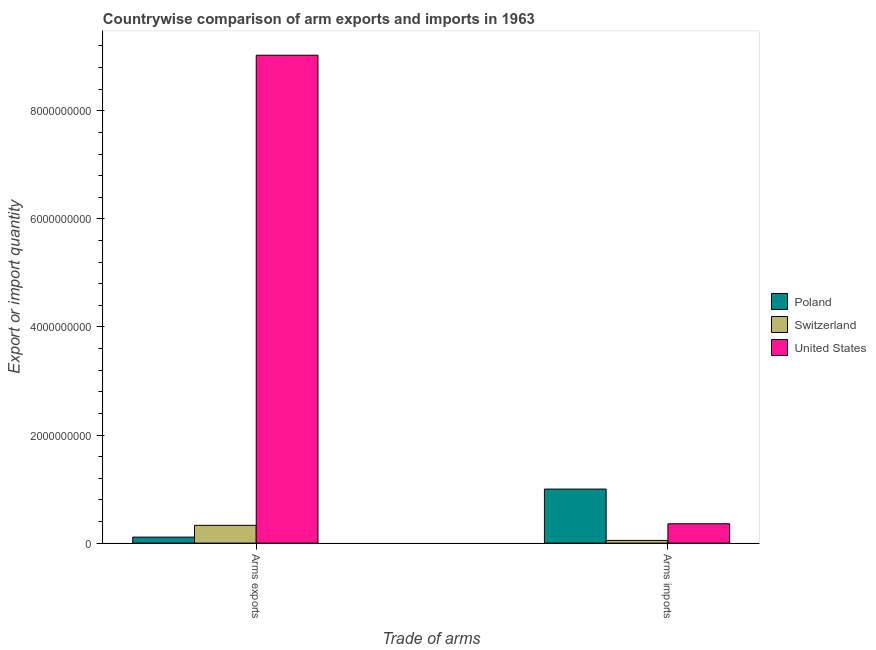How many different coloured bars are there?
Make the answer very short. 3. How many bars are there on the 2nd tick from the left?
Ensure brevity in your answer.  3. What is the label of the 2nd group of bars from the left?
Give a very brief answer. Arms imports. What is the arms imports in Switzerland?
Give a very brief answer. 5.00e+07. Across all countries, what is the maximum arms exports?
Provide a succinct answer. 9.03e+09. Across all countries, what is the minimum arms exports?
Offer a very short reply. 1.11e+08. What is the total arms imports in the graph?
Provide a short and direct response. 1.41e+09. What is the difference between the arms exports in United States and that in Switzerland?
Offer a very short reply. 8.70e+09. What is the difference between the arms exports in Poland and the arms imports in United States?
Ensure brevity in your answer.  -2.47e+08. What is the average arms imports per country?
Your answer should be compact. 4.69e+08. What is the difference between the arms imports and arms exports in Poland?
Your answer should be compact. 8.89e+08. In how many countries, is the arms imports greater than 7200000000 ?
Keep it short and to the point. 0. What is the ratio of the arms exports in United States to that in Switzerland?
Keep it short and to the point. 27.44. What does the 3rd bar from the left in Arms exports represents?
Your response must be concise. United States. What does the 1st bar from the right in Arms exports represents?
Your answer should be very brief. United States. What is the difference between two consecutive major ticks on the Y-axis?
Offer a terse response. 2.00e+09. Does the graph contain any zero values?
Your response must be concise. No. Does the graph contain grids?
Give a very brief answer. No. Where does the legend appear in the graph?
Make the answer very short. Center right. How many legend labels are there?
Offer a terse response. 3. How are the legend labels stacked?
Keep it short and to the point. Vertical. What is the title of the graph?
Your answer should be very brief. Countrywise comparison of arm exports and imports in 1963. What is the label or title of the X-axis?
Make the answer very short. Trade of arms. What is the label or title of the Y-axis?
Offer a very short reply. Export or import quantity. What is the Export or import quantity of Poland in Arms exports?
Ensure brevity in your answer.  1.11e+08. What is the Export or import quantity in Switzerland in Arms exports?
Ensure brevity in your answer.  3.29e+08. What is the Export or import quantity in United States in Arms exports?
Provide a succinct answer. 9.03e+09. What is the Export or import quantity of Poland in Arms imports?
Keep it short and to the point. 1.00e+09. What is the Export or import quantity in Switzerland in Arms imports?
Ensure brevity in your answer.  5.00e+07. What is the Export or import quantity in United States in Arms imports?
Your response must be concise. 3.58e+08. Across all Trade of arms, what is the maximum Export or import quantity of Switzerland?
Your answer should be very brief. 3.29e+08. Across all Trade of arms, what is the maximum Export or import quantity in United States?
Provide a succinct answer. 9.03e+09. Across all Trade of arms, what is the minimum Export or import quantity in Poland?
Make the answer very short. 1.11e+08. Across all Trade of arms, what is the minimum Export or import quantity in United States?
Ensure brevity in your answer.  3.58e+08. What is the total Export or import quantity of Poland in the graph?
Offer a terse response. 1.11e+09. What is the total Export or import quantity of Switzerland in the graph?
Offer a very short reply. 3.79e+08. What is the total Export or import quantity in United States in the graph?
Give a very brief answer. 9.39e+09. What is the difference between the Export or import quantity in Poland in Arms exports and that in Arms imports?
Offer a very short reply. -8.89e+08. What is the difference between the Export or import quantity of Switzerland in Arms exports and that in Arms imports?
Ensure brevity in your answer.  2.79e+08. What is the difference between the Export or import quantity of United States in Arms exports and that in Arms imports?
Provide a short and direct response. 8.67e+09. What is the difference between the Export or import quantity of Poland in Arms exports and the Export or import quantity of Switzerland in Arms imports?
Ensure brevity in your answer.  6.10e+07. What is the difference between the Export or import quantity in Poland in Arms exports and the Export or import quantity in United States in Arms imports?
Offer a terse response. -2.47e+08. What is the difference between the Export or import quantity in Switzerland in Arms exports and the Export or import quantity in United States in Arms imports?
Give a very brief answer. -2.90e+07. What is the average Export or import quantity of Poland per Trade of arms?
Provide a succinct answer. 5.56e+08. What is the average Export or import quantity in Switzerland per Trade of arms?
Offer a very short reply. 1.90e+08. What is the average Export or import quantity of United States per Trade of arms?
Offer a terse response. 4.69e+09. What is the difference between the Export or import quantity of Poland and Export or import quantity of Switzerland in Arms exports?
Offer a terse response. -2.18e+08. What is the difference between the Export or import quantity in Poland and Export or import quantity in United States in Arms exports?
Provide a short and direct response. -8.92e+09. What is the difference between the Export or import quantity in Switzerland and Export or import quantity in United States in Arms exports?
Offer a very short reply. -8.70e+09. What is the difference between the Export or import quantity in Poland and Export or import quantity in Switzerland in Arms imports?
Your answer should be compact. 9.50e+08. What is the difference between the Export or import quantity of Poland and Export or import quantity of United States in Arms imports?
Your answer should be very brief. 6.42e+08. What is the difference between the Export or import quantity of Switzerland and Export or import quantity of United States in Arms imports?
Your response must be concise. -3.08e+08. What is the ratio of the Export or import quantity in Poland in Arms exports to that in Arms imports?
Provide a short and direct response. 0.11. What is the ratio of the Export or import quantity in Switzerland in Arms exports to that in Arms imports?
Give a very brief answer. 6.58. What is the ratio of the Export or import quantity in United States in Arms exports to that in Arms imports?
Your answer should be compact. 25.22. What is the difference between the highest and the second highest Export or import quantity of Poland?
Offer a terse response. 8.89e+08. What is the difference between the highest and the second highest Export or import quantity of Switzerland?
Provide a succinct answer. 2.79e+08. What is the difference between the highest and the second highest Export or import quantity in United States?
Your answer should be very brief. 8.67e+09. What is the difference between the highest and the lowest Export or import quantity in Poland?
Give a very brief answer. 8.89e+08. What is the difference between the highest and the lowest Export or import quantity in Switzerland?
Give a very brief answer. 2.79e+08. What is the difference between the highest and the lowest Export or import quantity of United States?
Keep it short and to the point. 8.67e+09. 